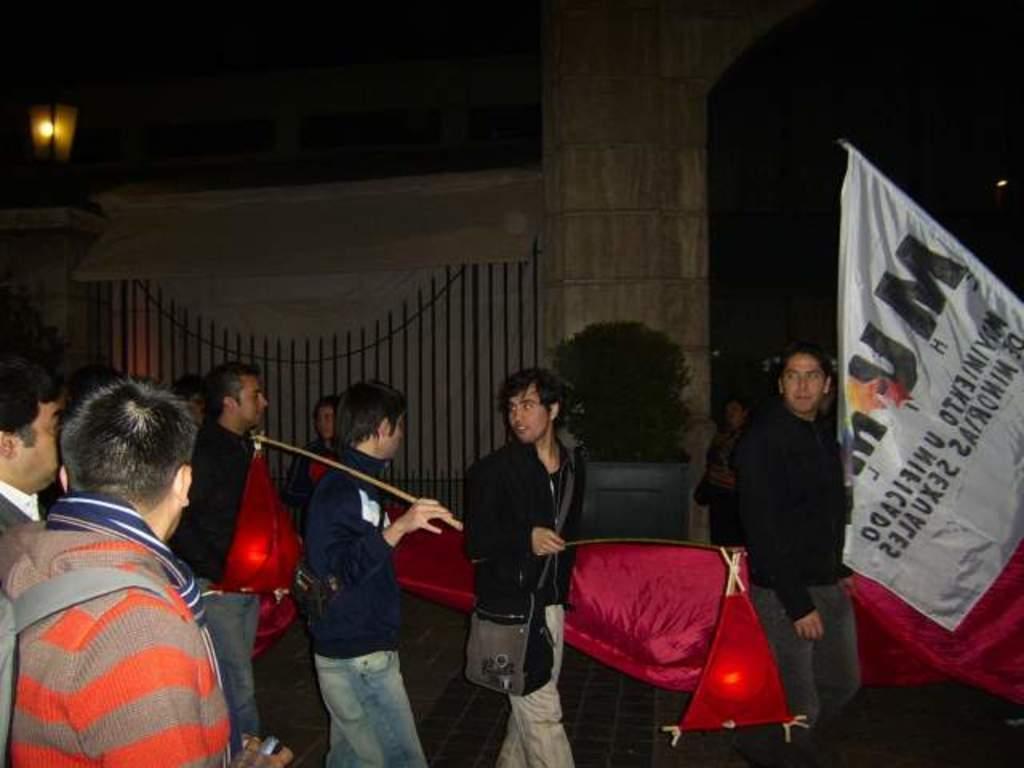Could you give a brief overview of what you see in this image? In this picture I can see there is a group of people walking and there is a white banner on right side and there is a fence in the backdrop and there is a pillar with a light. 